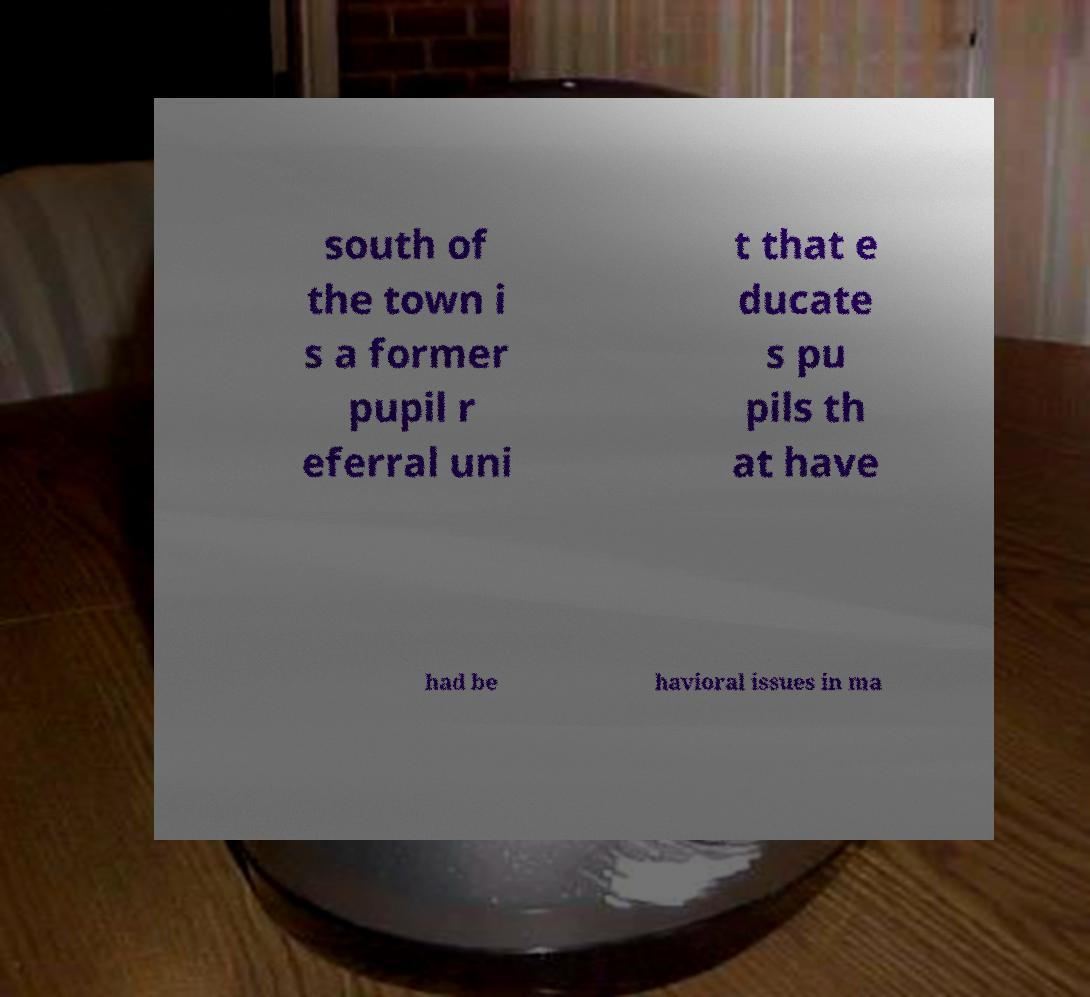I need the written content from this picture converted into text. Can you do that? south of the town i s a former pupil r eferral uni t that e ducate s pu pils th at have had be havioral issues in ma 